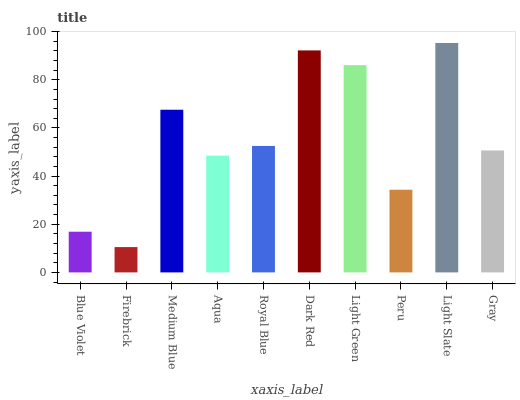Is Firebrick the minimum?
Answer yes or no. Yes. Is Light Slate the maximum?
Answer yes or no. Yes. Is Medium Blue the minimum?
Answer yes or no. No. Is Medium Blue the maximum?
Answer yes or no. No. Is Medium Blue greater than Firebrick?
Answer yes or no. Yes. Is Firebrick less than Medium Blue?
Answer yes or no. Yes. Is Firebrick greater than Medium Blue?
Answer yes or no. No. Is Medium Blue less than Firebrick?
Answer yes or no. No. Is Royal Blue the high median?
Answer yes or no. Yes. Is Gray the low median?
Answer yes or no. Yes. Is Firebrick the high median?
Answer yes or no. No. Is Medium Blue the low median?
Answer yes or no. No. 